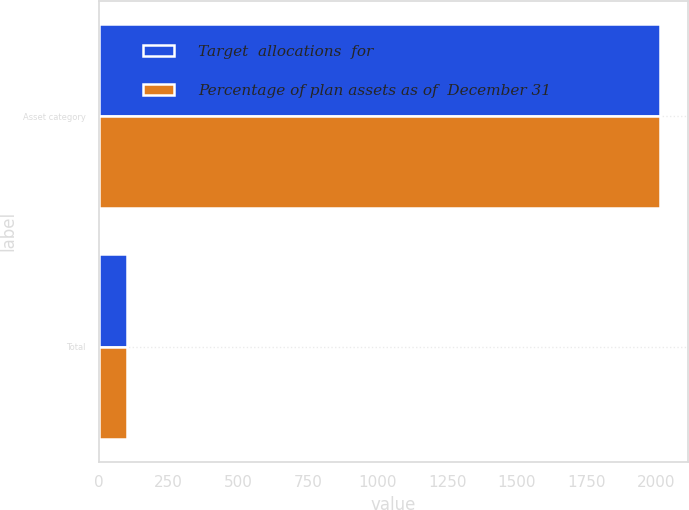Convert chart to OTSL. <chart><loc_0><loc_0><loc_500><loc_500><stacked_bar_chart><ecel><fcel>Asset category<fcel>Total<nl><fcel>Target  allocations  for<fcel>2015<fcel>100<nl><fcel>Percentage of plan assets as of  December 31<fcel>2014<fcel>100<nl></chart> 